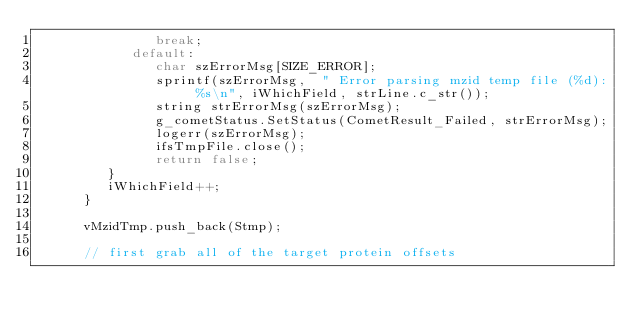<code> <loc_0><loc_0><loc_500><loc_500><_C++_>               break;
            default:
               char szErrorMsg[SIZE_ERROR];
               sprintf(szErrorMsg,  " Error parsing mzid temp file (%d): %s\n", iWhichField, strLine.c_str());
               string strErrorMsg(szErrorMsg);
               g_cometStatus.SetStatus(CometResult_Failed, strErrorMsg);
               logerr(szErrorMsg);
               ifsTmpFile.close();
               return false;
         }
         iWhichField++;
      }

      vMzidTmp.push_back(Stmp);

      // first grab all of the target protein offsets</code> 